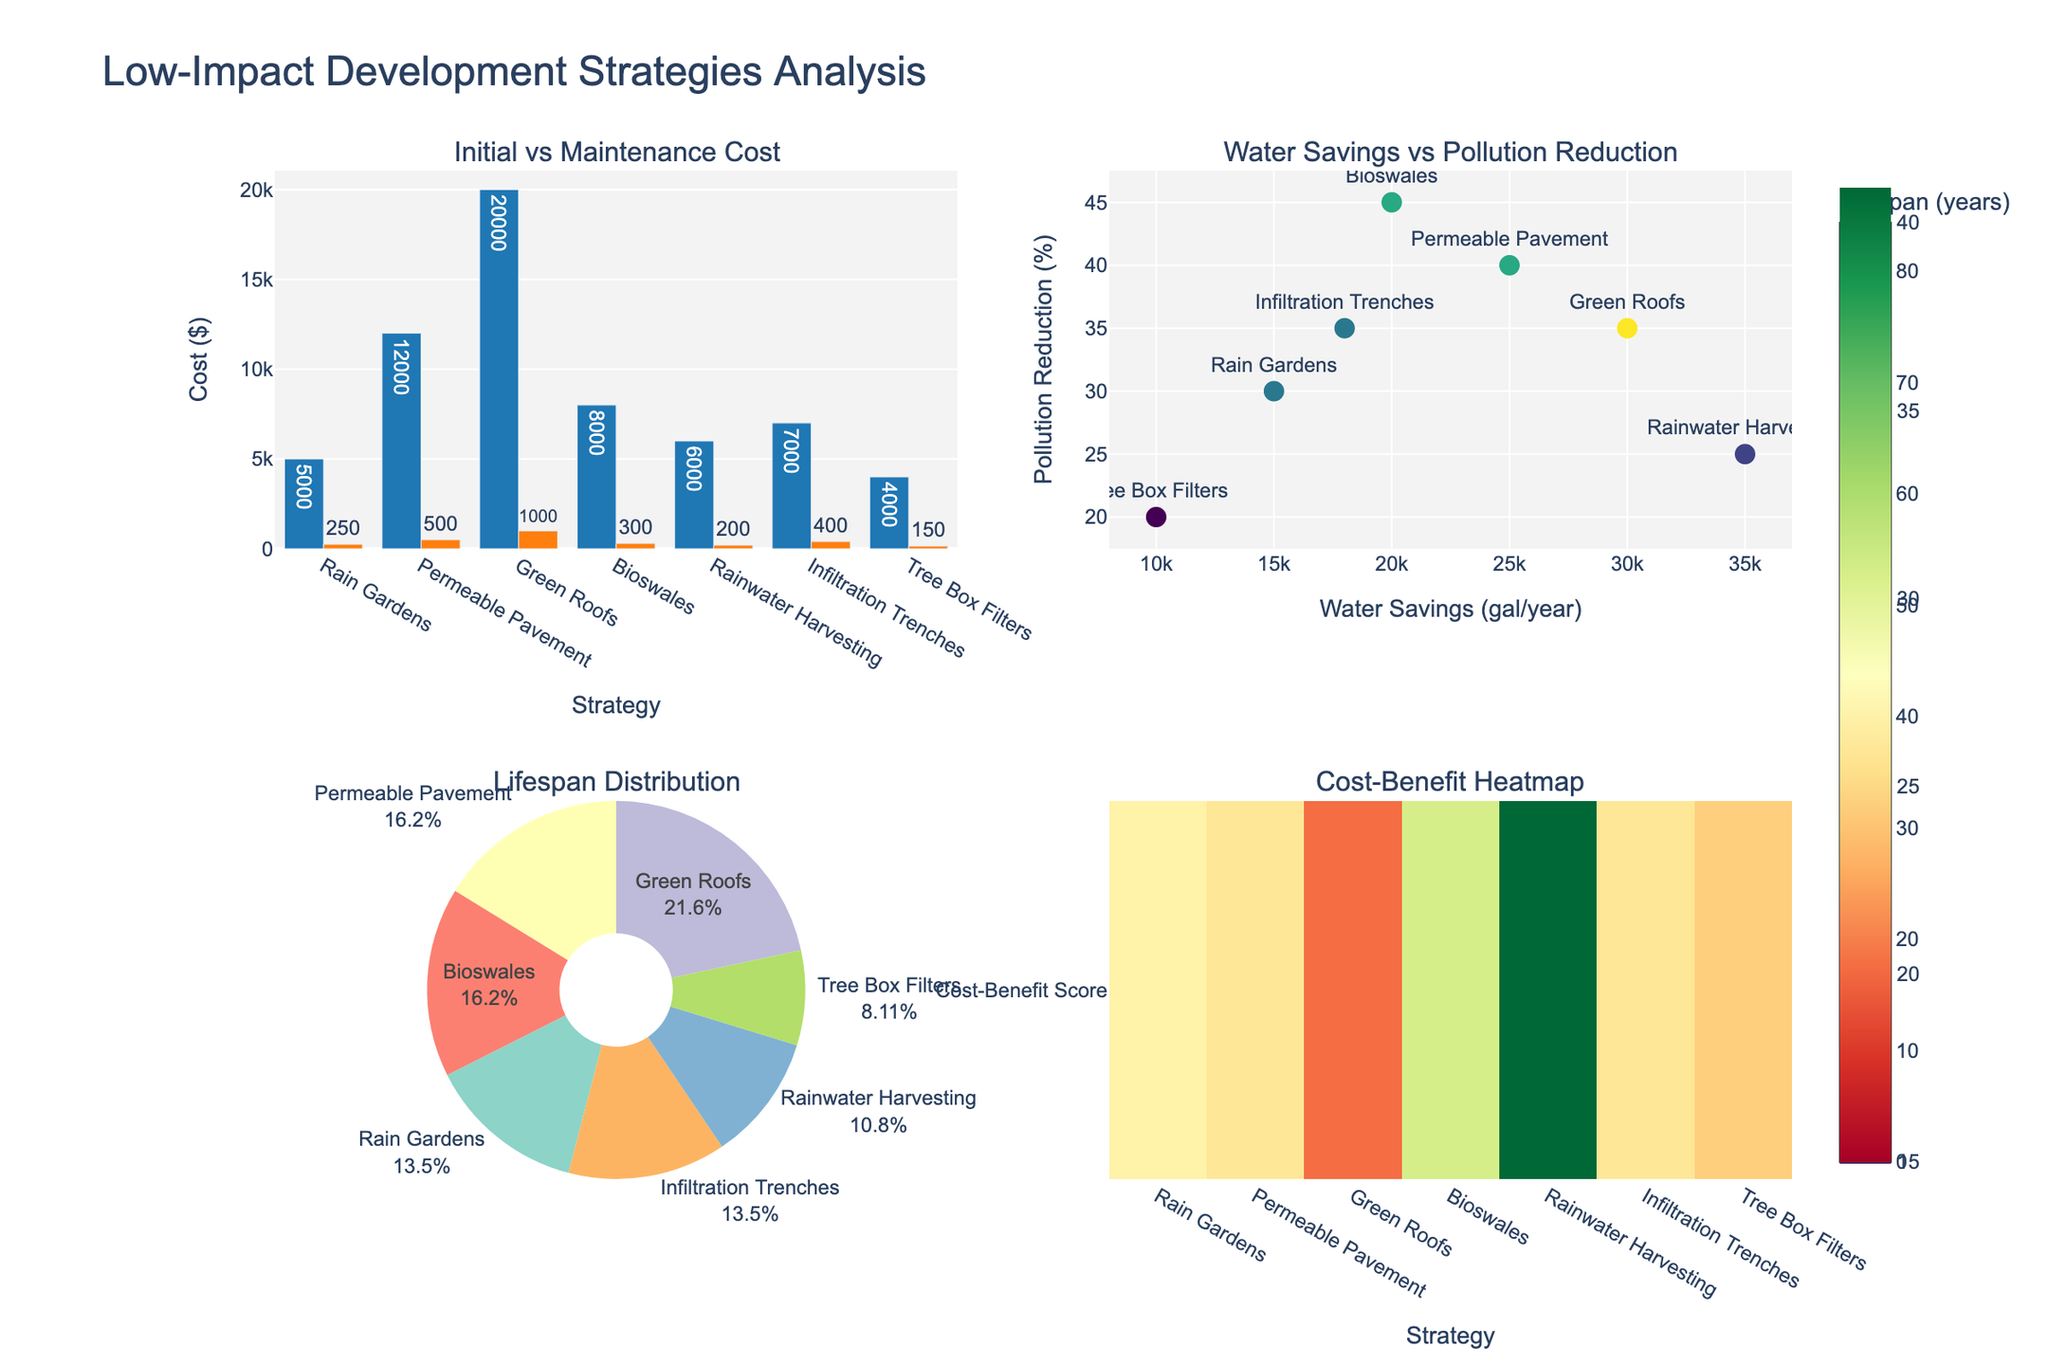What's the title of the figure? The title of the figure is located at the top center and is labeled as "Low-Impact Development Strategies Analysis".
Answer: Low-Impact Development Strategies Analysis What are the two columns in the bar chart subplot labeled? The labels on the x-axis and y-axis of the bar chart are "Strategy" and "Cost ($)" respectively.
Answer: Strategy and Cost ($) Which strategy has the lowest initial cost? Identify the bar with the smallest value on the bar chart. Tree Box Filters has the lowest initial cost of $4000.
Answer: Tree Box Filters Which strategy provides the highest water savings per year? In the Scatter plot, find the highest value on the x-axis (Water Savings). Rainwater Harvesting offers the maximum water savings of 35,000 gallons per year.
Answer: Rainwater Harvesting What is the total maintenance cost for Rain Gardens over its lifespan? Multiply the maintenance cost per year (250) by the lifespan in years (25). 250 * 25 = $6250.
Answer: $6250 Compare the initial cost and water savings of Permeable Pavement and Green Roofs. Which is more cost-effective in terms of initial cost per gallon saved? Initial cost per gallon for Permeable Pavement: 12000 / 25000 = $0.48/gal. Initial cost per gallon for Green Roofs: 20000 / 30000 = $0.67/gal. Permeable Pavement is more cost-effective.
Answer: Permeable Pavement Which strategy has the highest cost-benefit score in the heatmap subplot? In the heatmap, find the strategy with the highest color intensity. Bioswales show the highest cost-benefit score.
Answer: Bioswales What is the percentage share of Green Roofs in the total lifespan distribution? In the pie chart, identify the value of Green Roofs' slice. Green Roofs account for 40% of the total lifespan distribution.
Answer: 40% How does water savings correlate with pollution reduction across strategies? In the scatter plot, observe the trend between Water Savings on the x-axis and Pollution Reduction on the y-axis. There is a positive correlation where strategies with higher water savings generally show greater pollution reduction.
Answer: Positive correlation Among all strategies, which two have nearly identical initial costs? Compare the bars in the bar chart for similar heights. Rainwater Harvesting and Infiltration Trenches both have initial costs close to $6000-$7000.
Answer: Rainwater Harvesting and Infiltration Trenches 